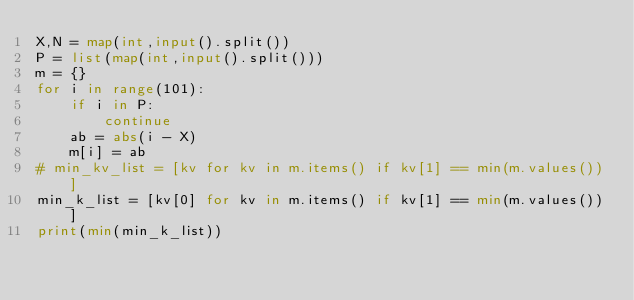<code> <loc_0><loc_0><loc_500><loc_500><_Python_>X,N = map(int,input().split())
P = list(map(int,input().split()))
m = {}
for i in range(101):
    if i in P:
        continue
    ab = abs(i - X)
    m[i] = ab
# min_kv_list = [kv for kv in m.items() if kv[1] == min(m.values())]
min_k_list = [kv[0] for kv in m.items() if kv[1] == min(m.values())]
print(min(min_k_list))
</code> 